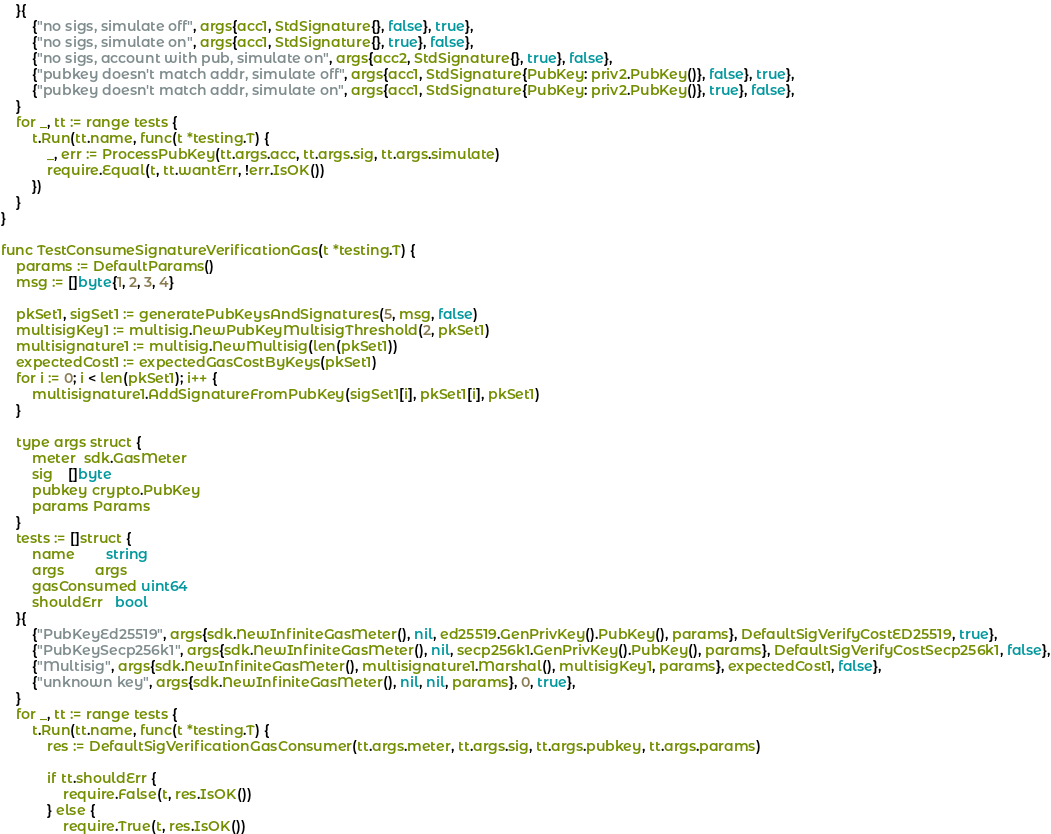Convert code to text. <code><loc_0><loc_0><loc_500><loc_500><_Go_>	}{
		{"no sigs, simulate off", args{acc1, StdSignature{}, false}, true},
		{"no sigs, simulate on", args{acc1, StdSignature{}, true}, false},
		{"no sigs, account with pub, simulate on", args{acc2, StdSignature{}, true}, false},
		{"pubkey doesn't match addr, simulate off", args{acc1, StdSignature{PubKey: priv2.PubKey()}, false}, true},
		{"pubkey doesn't match addr, simulate on", args{acc1, StdSignature{PubKey: priv2.PubKey()}, true}, false},
	}
	for _, tt := range tests {
		t.Run(tt.name, func(t *testing.T) {
			_, err := ProcessPubKey(tt.args.acc, tt.args.sig, tt.args.simulate)
			require.Equal(t, tt.wantErr, !err.IsOK())
		})
	}
}

func TestConsumeSignatureVerificationGas(t *testing.T) {
	params := DefaultParams()
	msg := []byte{1, 2, 3, 4}

	pkSet1, sigSet1 := generatePubKeysAndSignatures(5, msg, false)
	multisigKey1 := multisig.NewPubKeyMultisigThreshold(2, pkSet1)
	multisignature1 := multisig.NewMultisig(len(pkSet1))
	expectedCost1 := expectedGasCostByKeys(pkSet1)
	for i := 0; i < len(pkSet1); i++ {
		multisignature1.AddSignatureFromPubKey(sigSet1[i], pkSet1[i], pkSet1)
	}

	type args struct {
		meter  sdk.GasMeter
		sig    []byte
		pubkey crypto.PubKey
		params Params
	}
	tests := []struct {
		name        string
		args        args
		gasConsumed uint64
		shouldErr   bool
	}{
		{"PubKeyEd25519", args{sdk.NewInfiniteGasMeter(), nil, ed25519.GenPrivKey().PubKey(), params}, DefaultSigVerifyCostED25519, true},
		{"PubKeySecp256k1", args{sdk.NewInfiniteGasMeter(), nil, secp256k1.GenPrivKey().PubKey(), params}, DefaultSigVerifyCostSecp256k1, false},
		{"Multisig", args{sdk.NewInfiniteGasMeter(), multisignature1.Marshal(), multisigKey1, params}, expectedCost1, false},
		{"unknown key", args{sdk.NewInfiniteGasMeter(), nil, nil, params}, 0, true},
	}
	for _, tt := range tests {
		t.Run(tt.name, func(t *testing.T) {
			res := DefaultSigVerificationGasConsumer(tt.args.meter, tt.args.sig, tt.args.pubkey, tt.args.params)

			if tt.shouldErr {
				require.False(t, res.IsOK())
			} else {
				require.True(t, res.IsOK())</code> 